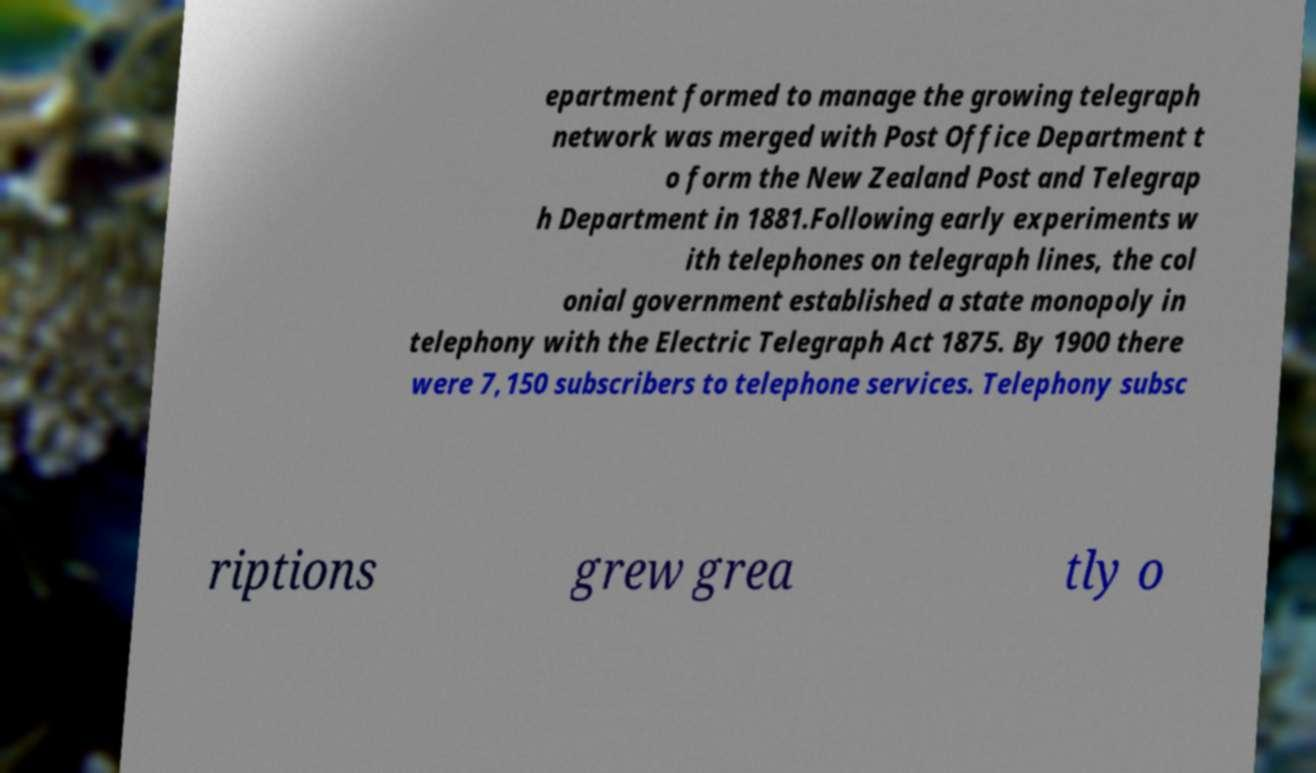Could you assist in decoding the text presented in this image and type it out clearly? epartment formed to manage the growing telegraph network was merged with Post Office Department t o form the New Zealand Post and Telegrap h Department in 1881.Following early experiments w ith telephones on telegraph lines, the col onial government established a state monopoly in telephony with the Electric Telegraph Act 1875. By 1900 there were 7,150 subscribers to telephone services. Telephony subsc riptions grew grea tly o 